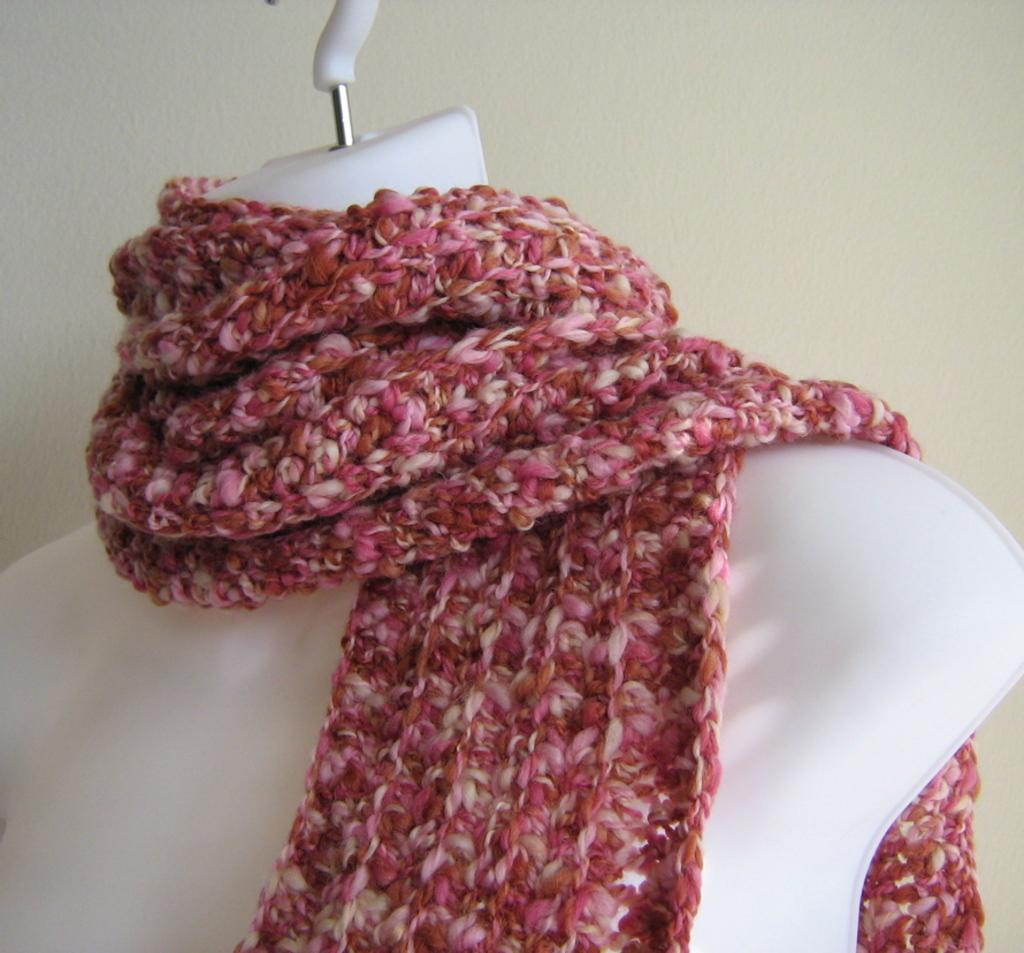What is the main subject in the image? There is a mannequin in the image. What is the mannequin wearing? The mannequin is wearing a scarf. What can be seen in the background of the image? There is a wall in the background of the image. Where is the guide leading the group of tourists in the image? There is no guide or group of tourists present in the image; it only features a mannequin wearing a scarf and a wall in the background. 